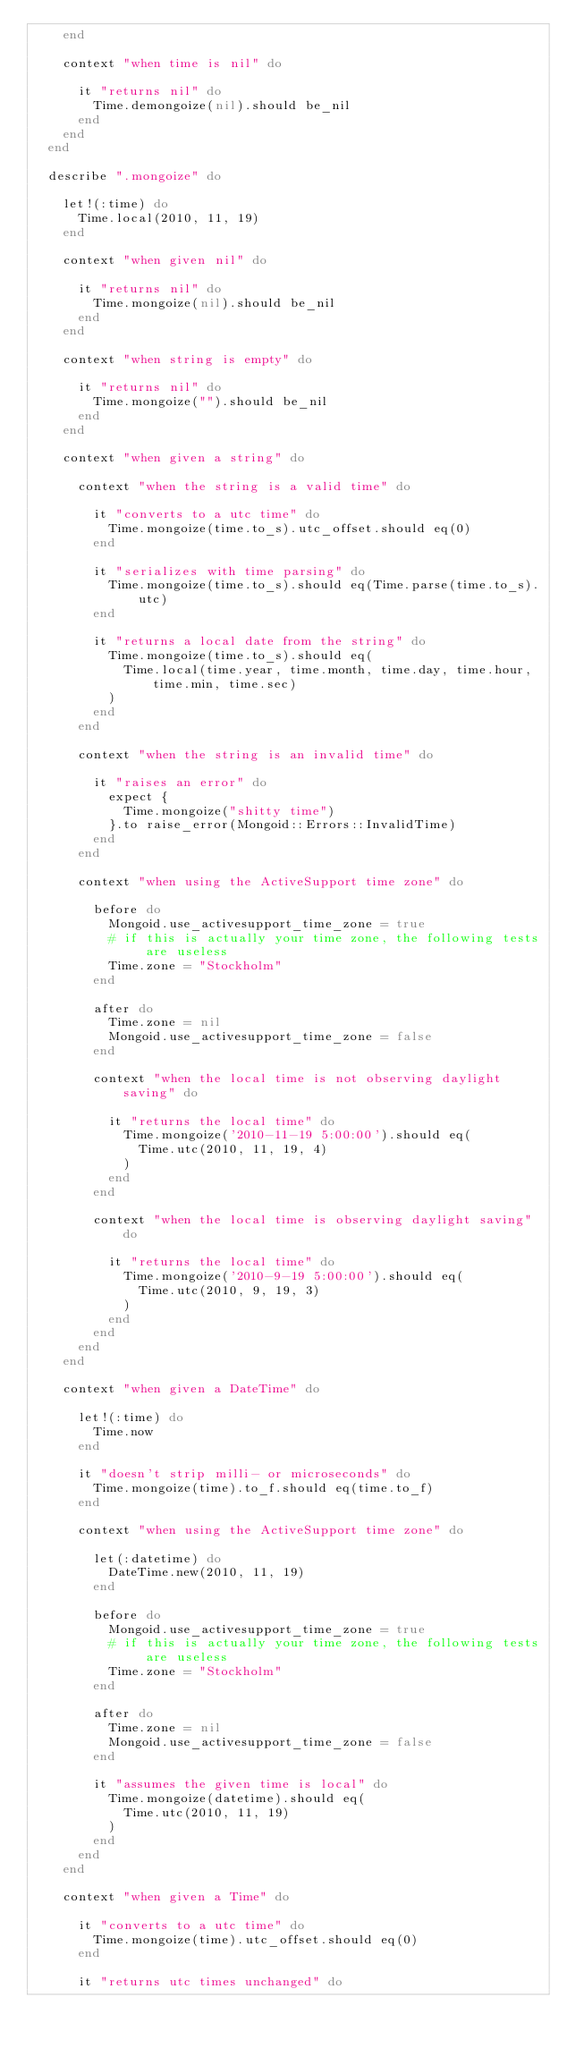<code> <loc_0><loc_0><loc_500><loc_500><_Ruby_>    end

    context "when time is nil" do

      it "returns nil" do
        Time.demongoize(nil).should be_nil
      end
    end
  end

  describe ".mongoize" do

    let!(:time) do
      Time.local(2010, 11, 19)
    end

    context "when given nil" do

      it "returns nil" do
        Time.mongoize(nil).should be_nil
      end
    end

    context "when string is empty" do

      it "returns nil" do
        Time.mongoize("").should be_nil
      end
    end

    context "when given a string" do

      context "when the string is a valid time" do

        it "converts to a utc time" do
          Time.mongoize(time.to_s).utc_offset.should eq(0)
        end

        it "serializes with time parsing" do
          Time.mongoize(time.to_s).should eq(Time.parse(time.to_s).utc)
        end

        it "returns a local date from the string" do
          Time.mongoize(time.to_s).should eq(
            Time.local(time.year, time.month, time.day, time.hour, time.min, time.sec)
          )
        end
      end

      context "when the string is an invalid time" do

        it "raises an error" do
          expect {
            Time.mongoize("shitty time")
          }.to raise_error(Mongoid::Errors::InvalidTime)
        end
      end

      context "when using the ActiveSupport time zone" do

        before do
          Mongoid.use_activesupport_time_zone = true
          # if this is actually your time zone, the following tests are useless
          Time.zone = "Stockholm"
        end

        after do
          Time.zone = nil
          Mongoid.use_activesupport_time_zone = false
        end

        context "when the local time is not observing daylight saving" do

          it "returns the local time" do
            Time.mongoize('2010-11-19 5:00:00').should eq(
              Time.utc(2010, 11, 19, 4)
            )
          end
        end

        context "when the local time is observing daylight saving" do

          it "returns the local time" do
            Time.mongoize('2010-9-19 5:00:00').should eq(
              Time.utc(2010, 9, 19, 3)
            )
          end
        end
      end
    end

    context "when given a DateTime" do

      let!(:time) do
        Time.now
      end

      it "doesn't strip milli- or microseconds" do
        Time.mongoize(time).to_f.should eq(time.to_f)
      end

      context "when using the ActiveSupport time zone" do

        let(:datetime) do
          DateTime.new(2010, 11, 19)
        end

        before do
          Mongoid.use_activesupport_time_zone = true
          # if this is actually your time zone, the following tests are useless
          Time.zone = "Stockholm"
        end

        after do
          Time.zone = nil
          Mongoid.use_activesupport_time_zone = false
        end

        it "assumes the given time is local" do
          Time.mongoize(datetime).should eq(
            Time.utc(2010, 11, 19)
          )
        end
      end
    end

    context "when given a Time" do

      it "converts to a utc time" do
        Time.mongoize(time).utc_offset.should eq(0)
      end

      it "returns utc times unchanged" do</code> 